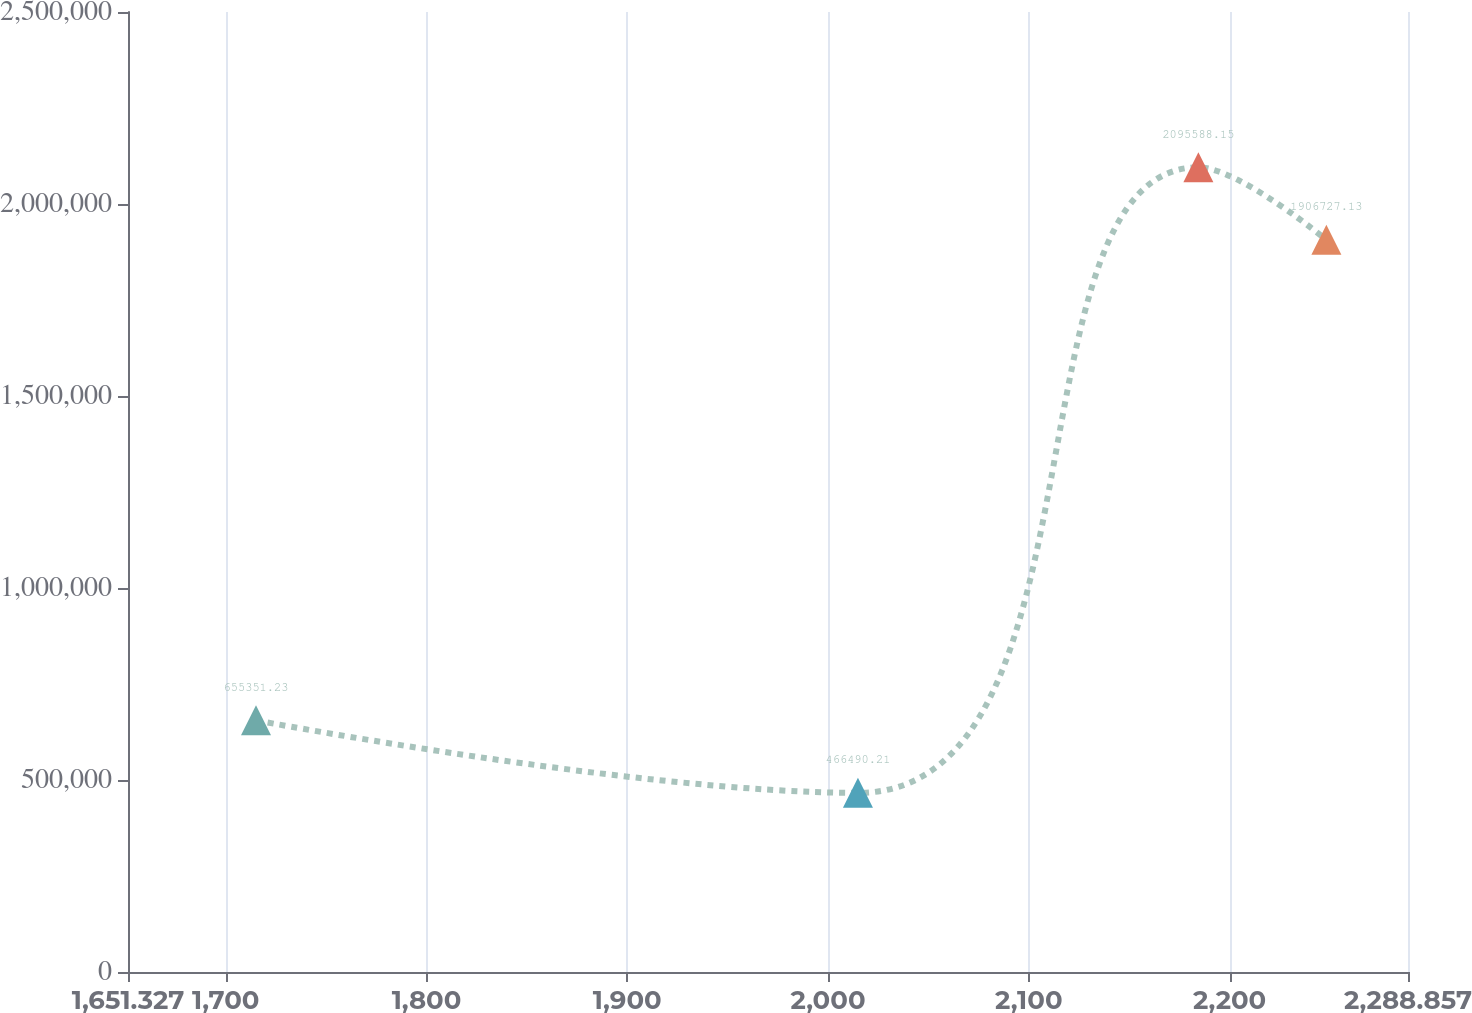<chart> <loc_0><loc_0><loc_500><loc_500><line_chart><ecel><fcel>Unnamed: 1<nl><fcel>1715.08<fcel>655351<nl><fcel>2014.9<fcel>466490<nl><fcel>2184.45<fcel>2.09559e+06<nl><fcel>2248.2<fcel>1.90673e+06<nl><fcel>2352.61<fcel>2.3551e+06<nl></chart> 